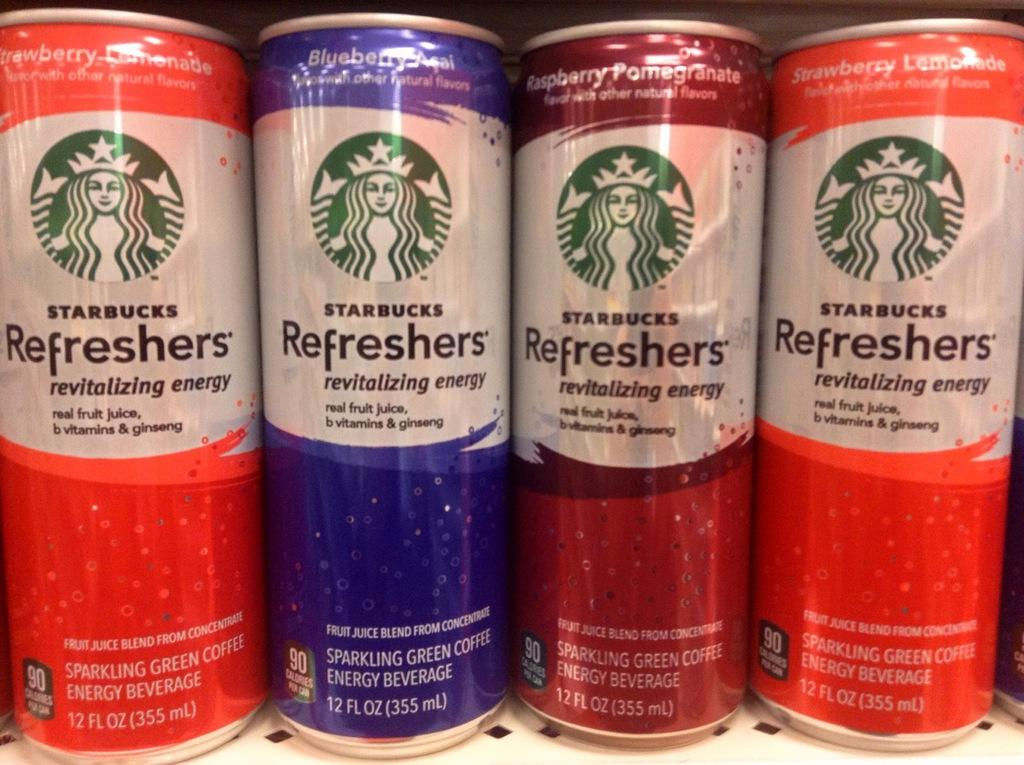<image>
Describe the image concisely. Starbucks refresher cans of different flavors sit on a shelf. 